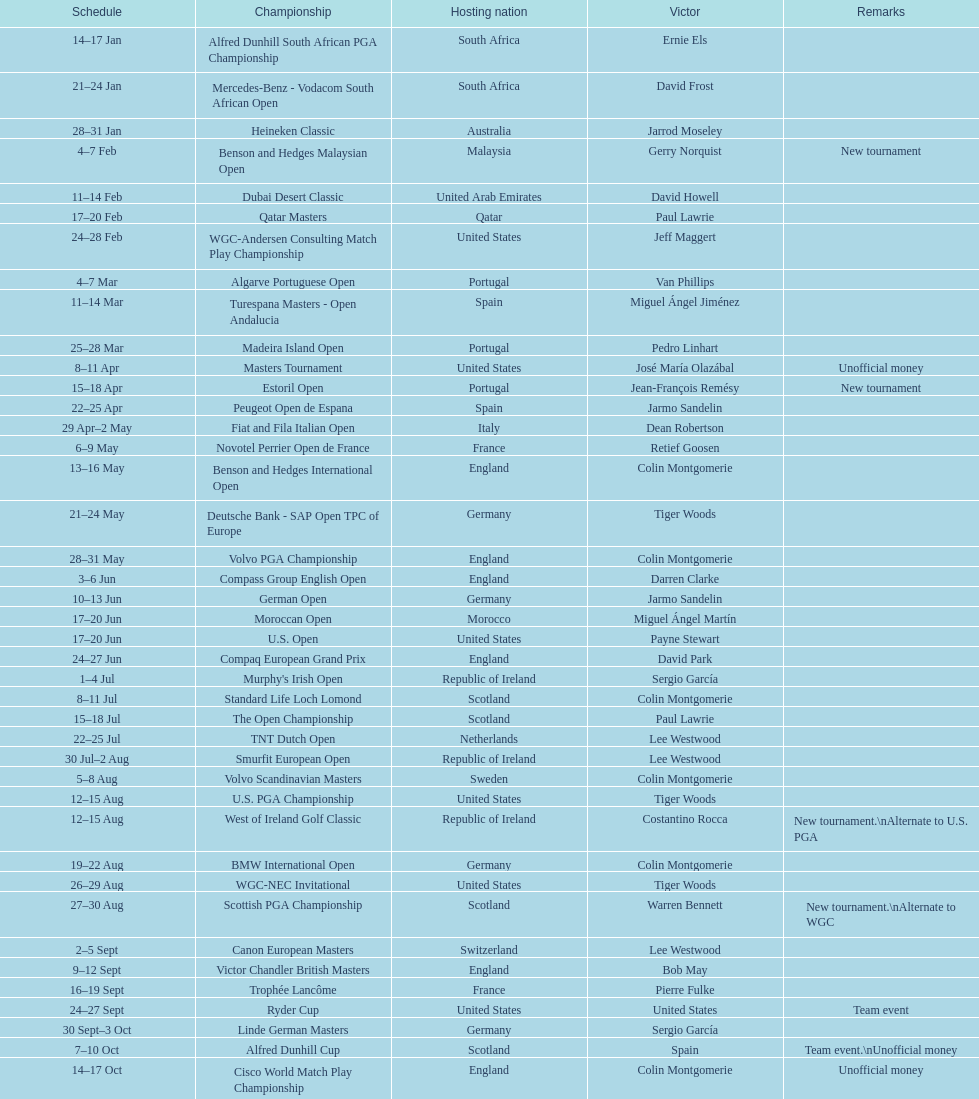Which competition took place more recently, the volvo pga or the algarve portuguese open? Volvo PGA. 